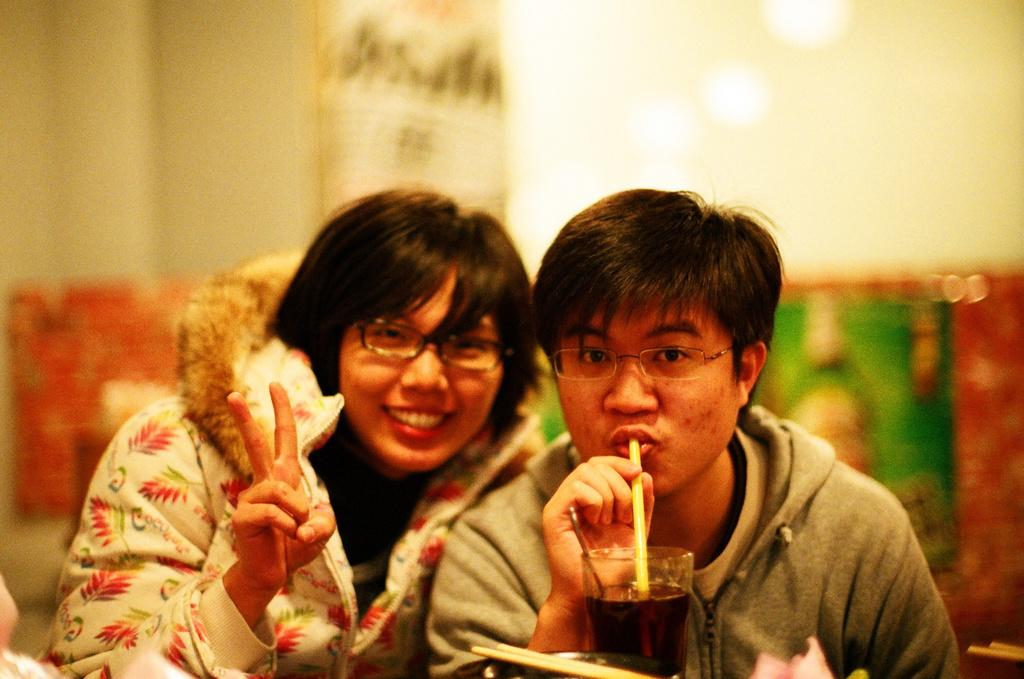How many people are in the image? There are a few people in the image. What is one person doing in the image? One person is drinking some liquid. Can you describe the background of the image? The background of the image is blurred. What can be seen at the bottom of the image? There are objects at the bottom of the image. What type of sweater is the person wearing in the image? There is no sweater mentioned or visible in the image. Can you describe the road in the image? There is no road present in the image. 